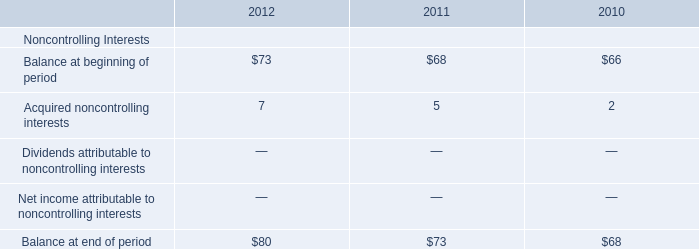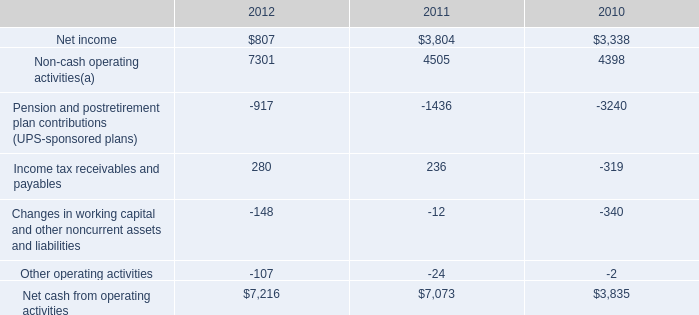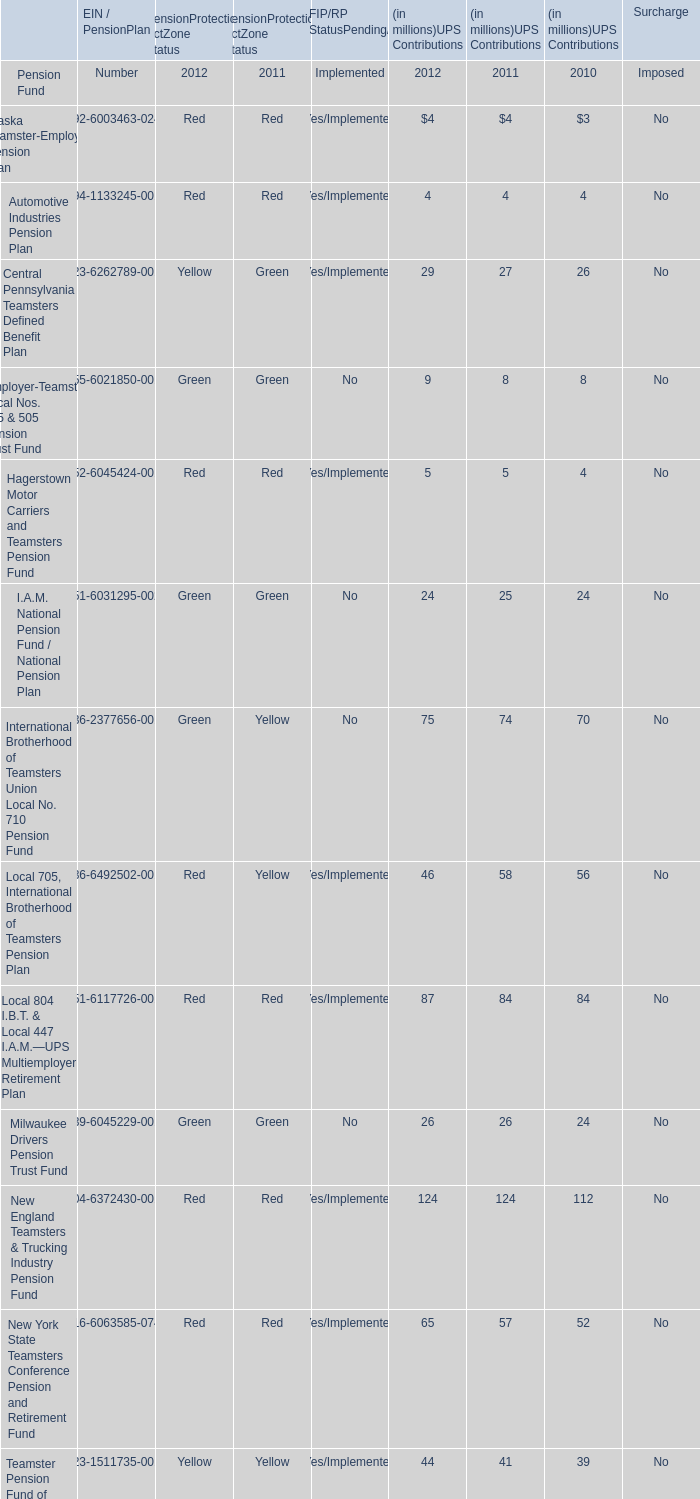What is the ratio of Central Pennsylvania Teamsters Defined Benefit Plan of UPS Contributions in Table 2 to the Acquired noncontrolling interests in Table 0 in 2012? 
Computations: (29 / 7)
Answer: 4.14286. 